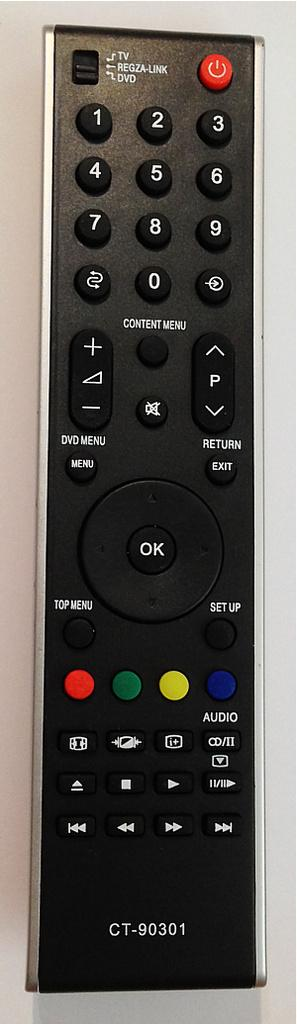What object can be seen in the image? There is a remote in the image. What is the color of the remote? The remote is black in color. What colors are the buttons on the remote? A: The remote has red, green, yellow, blue, and black color buttons. What type of structure can be seen in the mouth of the remote in the image? There is no structure present in the mouth of the remote, as remotes do not have mouths. 